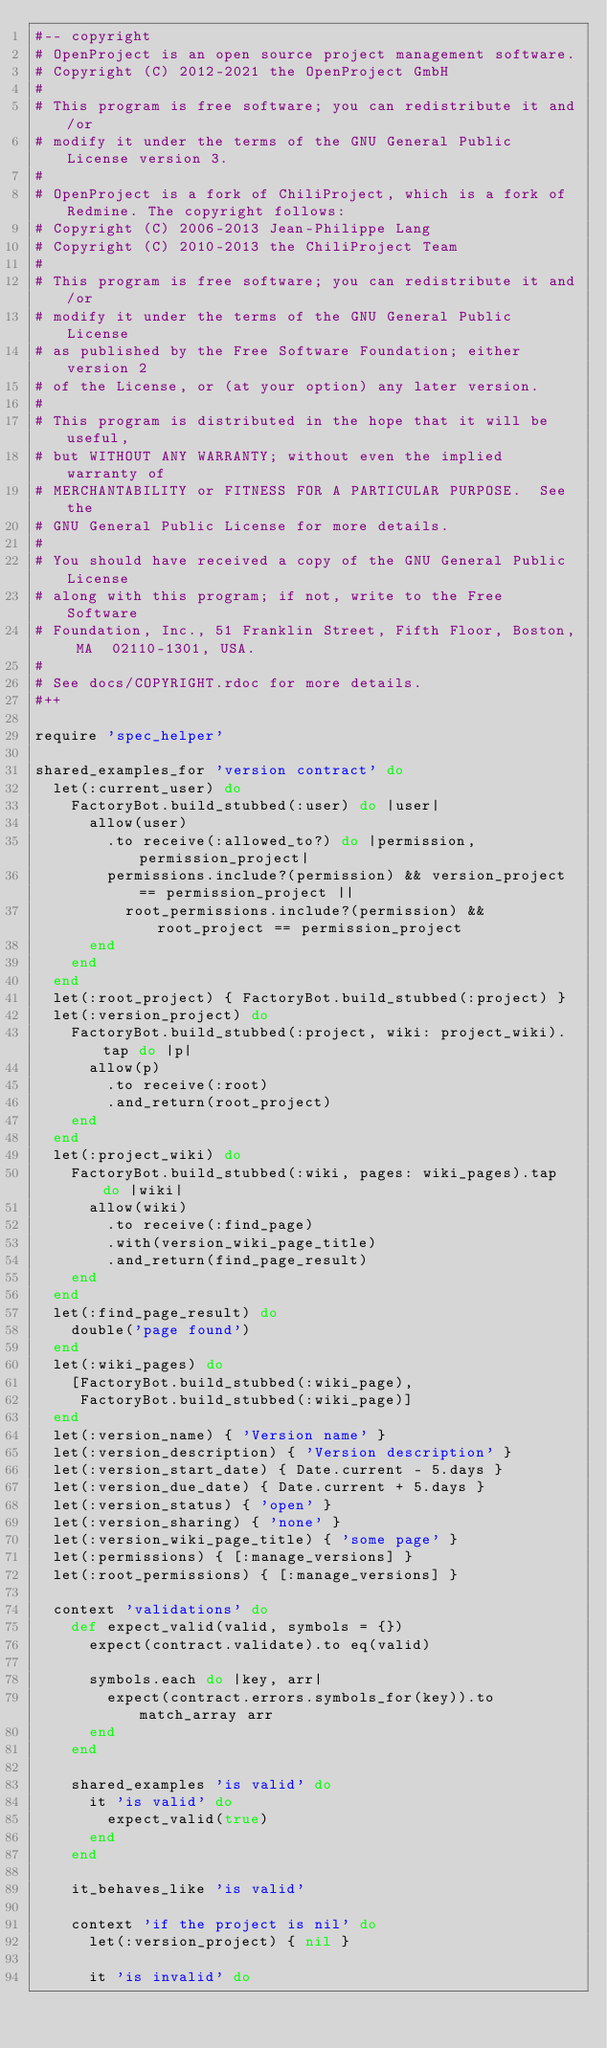<code> <loc_0><loc_0><loc_500><loc_500><_Ruby_>#-- copyright
# OpenProject is an open source project management software.
# Copyright (C) 2012-2021 the OpenProject GmbH
#
# This program is free software; you can redistribute it and/or
# modify it under the terms of the GNU General Public License version 3.
#
# OpenProject is a fork of ChiliProject, which is a fork of Redmine. The copyright follows:
# Copyright (C) 2006-2013 Jean-Philippe Lang
# Copyright (C) 2010-2013 the ChiliProject Team
#
# This program is free software; you can redistribute it and/or
# modify it under the terms of the GNU General Public License
# as published by the Free Software Foundation; either version 2
# of the License, or (at your option) any later version.
#
# This program is distributed in the hope that it will be useful,
# but WITHOUT ANY WARRANTY; without even the implied warranty of
# MERCHANTABILITY or FITNESS FOR A PARTICULAR PURPOSE.  See the
# GNU General Public License for more details.
#
# You should have received a copy of the GNU General Public License
# along with this program; if not, write to the Free Software
# Foundation, Inc., 51 Franklin Street, Fifth Floor, Boston, MA  02110-1301, USA.
#
# See docs/COPYRIGHT.rdoc for more details.
#++

require 'spec_helper'

shared_examples_for 'version contract' do
  let(:current_user) do
    FactoryBot.build_stubbed(:user) do |user|
      allow(user)
        .to receive(:allowed_to?) do |permission, permission_project|
        permissions.include?(permission) && version_project == permission_project ||
          root_permissions.include?(permission) && root_project == permission_project
      end
    end
  end
  let(:root_project) { FactoryBot.build_stubbed(:project) }
  let(:version_project) do
    FactoryBot.build_stubbed(:project, wiki: project_wiki).tap do |p|
      allow(p)
        .to receive(:root)
        .and_return(root_project)
    end
  end
  let(:project_wiki) do
    FactoryBot.build_stubbed(:wiki, pages: wiki_pages).tap do |wiki|
      allow(wiki)
        .to receive(:find_page)
        .with(version_wiki_page_title)
        .and_return(find_page_result)
    end
  end
  let(:find_page_result) do
    double('page found')
  end
  let(:wiki_pages) do
    [FactoryBot.build_stubbed(:wiki_page),
     FactoryBot.build_stubbed(:wiki_page)]
  end
  let(:version_name) { 'Version name' }
  let(:version_description) { 'Version description' }
  let(:version_start_date) { Date.current - 5.days }
  let(:version_due_date) { Date.current + 5.days }
  let(:version_status) { 'open' }
  let(:version_sharing) { 'none' }
  let(:version_wiki_page_title) { 'some page' }
  let(:permissions) { [:manage_versions] }
  let(:root_permissions) { [:manage_versions] }

  context 'validations' do
    def expect_valid(valid, symbols = {})
      expect(contract.validate).to eq(valid)

      symbols.each do |key, arr|
        expect(contract.errors.symbols_for(key)).to match_array arr
      end
    end

    shared_examples 'is valid' do
      it 'is valid' do
        expect_valid(true)
      end
    end

    it_behaves_like 'is valid'

    context 'if the project is nil' do
      let(:version_project) { nil }

      it 'is invalid' do</code> 